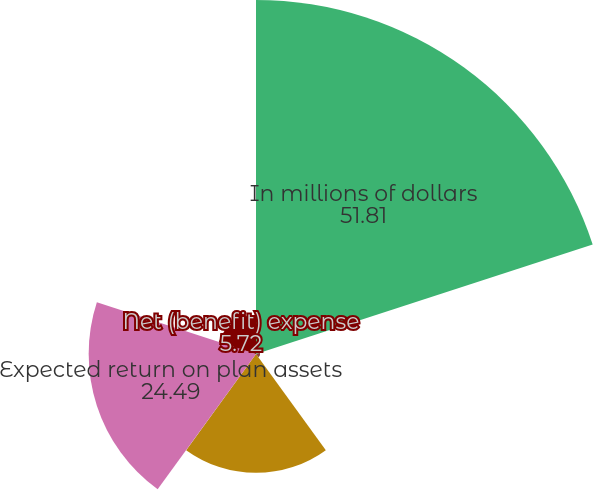Convert chart. <chart><loc_0><loc_0><loc_500><loc_500><pie_chart><fcel>In millions of dollars<fcel>Benefits earned during the<fcel>Interest cost on benefit<fcel>Expected return on plan assets<fcel>Net (benefit) expense<nl><fcel>51.81%<fcel>0.59%<fcel>17.39%<fcel>24.49%<fcel>5.72%<nl></chart> 